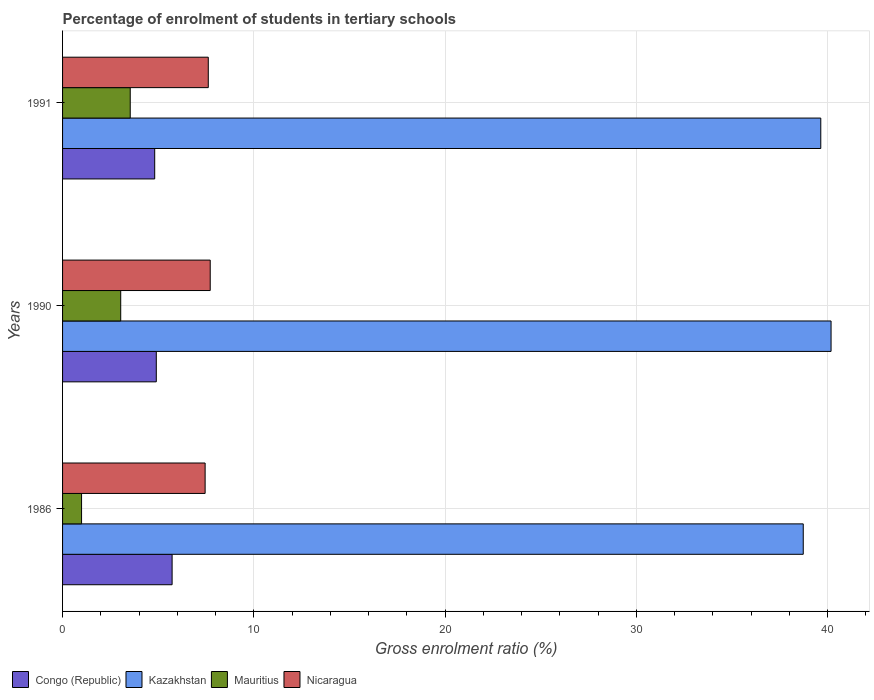Are the number of bars per tick equal to the number of legend labels?
Make the answer very short. Yes. How many bars are there on the 2nd tick from the top?
Make the answer very short. 4. How many bars are there on the 2nd tick from the bottom?
Your response must be concise. 4. What is the percentage of students enrolled in tertiary schools in Mauritius in 1991?
Your response must be concise. 3.54. Across all years, what is the maximum percentage of students enrolled in tertiary schools in Nicaragua?
Ensure brevity in your answer.  7.72. Across all years, what is the minimum percentage of students enrolled in tertiary schools in Nicaragua?
Ensure brevity in your answer.  7.45. In which year was the percentage of students enrolled in tertiary schools in Congo (Republic) maximum?
Offer a terse response. 1986. In which year was the percentage of students enrolled in tertiary schools in Congo (Republic) minimum?
Ensure brevity in your answer.  1991. What is the total percentage of students enrolled in tertiary schools in Congo (Republic) in the graph?
Offer a very short reply. 15.45. What is the difference between the percentage of students enrolled in tertiary schools in Congo (Republic) in 1986 and that in 1991?
Your answer should be compact. 0.91. What is the difference between the percentage of students enrolled in tertiary schools in Mauritius in 1991 and the percentage of students enrolled in tertiary schools in Nicaragua in 1986?
Give a very brief answer. -3.92. What is the average percentage of students enrolled in tertiary schools in Kazakhstan per year?
Ensure brevity in your answer.  39.52. In the year 1986, what is the difference between the percentage of students enrolled in tertiary schools in Mauritius and percentage of students enrolled in tertiary schools in Kazakhstan?
Offer a terse response. -37.74. In how many years, is the percentage of students enrolled in tertiary schools in Nicaragua greater than 16 %?
Give a very brief answer. 0. What is the ratio of the percentage of students enrolled in tertiary schools in Nicaragua in 1986 to that in 1990?
Your response must be concise. 0.97. What is the difference between the highest and the second highest percentage of students enrolled in tertiary schools in Nicaragua?
Make the answer very short. 0.1. What is the difference between the highest and the lowest percentage of students enrolled in tertiary schools in Mauritius?
Your answer should be compact. 2.55. Is the sum of the percentage of students enrolled in tertiary schools in Mauritius in 1986 and 1990 greater than the maximum percentage of students enrolled in tertiary schools in Nicaragua across all years?
Ensure brevity in your answer.  No. Is it the case that in every year, the sum of the percentage of students enrolled in tertiary schools in Kazakhstan and percentage of students enrolled in tertiary schools in Nicaragua is greater than the sum of percentage of students enrolled in tertiary schools in Mauritius and percentage of students enrolled in tertiary schools in Congo (Republic)?
Provide a succinct answer. No. What does the 1st bar from the top in 1991 represents?
Your response must be concise. Nicaragua. What does the 3rd bar from the bottom in 1990 represents?
Your response must be concise. Mauritius. Is it the case that in every year, the sum of the percentage of students enrolled in tertiary schools in Nicaragua and percentage of students enrolled in tertiary schools in Kazakhstan is greater than the percentage of students enrolled in tertiary schools in Congo (Republic)?
Your answer should be very brief. Yes. How many bars are there?
Offer a very short reply. 12. How many years are there in the graph?
Provide a short and direct response. 3. What is the difference between two consecutive major ticks on the X-axis?
Offer a very short reply. 10. Are the values on the major ticks of X-axis written in scientific E-notation?
Offer a very short reply. No. Does the graph contain any zero values?
Offer a terse response. No. Does the graph contain grids?
Provide a succinct answer. Yes. What is the title of the graph?
Your answer should be compact. Percentage of enrolment of students in tertiary schools. Does "Mali" appear as one of the legend labels in the graph?
Provide a succinct answer. No. What is the label or title of the Y-axis?
Make the answer very short. Years. What is the Gross enrolment ratio (%) of Congo (Republic) in 1986?
Give a very brief answer. 5.73. What is the Gross enrolment ratio (%) of Kazakhstan in 1986?
Provide a short and direct response. 38.73. What is the Gross enrolment ratio (%) of Mauritius in 1986?
Make the answer very short. 0.99. What is the Gross enrolment ratio (%) in Nicaragua in 1986?
Ensure brevity in your answer.  7.45. What is the Gross enrolment ratio (%) of Congo (Republic) in 1990?
Provide a short and direct response. 4.9. What is the Gross enrolment ratio (%) of Kazakhstan in 1990?
Your response must be concise. 40.19. What is the Gross enrolment ratio (%) in Mauritius in 1990?
Make the answer very short. 3.04. What is the Gross enrolment ratio (%) in Nicaragua in 1990?
Offer a terse response. 7.72. What is the Gross enrolment ratio (%) in Congo (Republic) in 1991?
Ensure brevity in your answer.  4.82. What is the Gross enrolment ratio (%) of Kazakhstan in 1991?
Make the answer very short. 39.65. What is the Gross enrolment ratio (%) in Mauritius in 1991?
Offer a terse response. 3.54. What is the Gross enrolment ratio (%) of Nicaragua in 1991?
Provide a short and direct response. 7.62. Across all years, what is the maximum Gross enrolment ratio (%) of Congo (Republic)?
Offer a terse response. 5.73. Across all years, what is the maximum Gross enrolment ratio (%) of Kazakhstan?
Make the answer very short. 40.19. Across all years, what is the maximum Gross enrolment ratio (%) in Mauritius?
Your answer should be very brief. 3.54. Across all years, what is the maximum Gross enrolment ratio (%) of Nicaragua?
Offer a terse response. 7.72. Across all years, what is the minimum Gross enrolment ratio (%) in Congo (Republic)?
Keep it short and to the point. 4.82. Across all years, what is the minimum Gross enrolment ratio (%) in Kazakhstan?
Ensure brevity in your answer.  38.73. Across all years, what is the minimum Gross enrolment ratio (%) of Nicaragua?
Make the answer very short. 7.45. What is the total Gross enrolment ratio (%) in Congo (Republic) in the graph?
Make the answer very short. 15.45. What is the total Gross enrolment ratio (%) of Kazakhstan in the graph?
Your response must be concise. 118.57. What is the total Gross enrolment ratio (%) in Mauritius in the graph?
Your answer should be very brief. 7.57. What is the total Gross enrolment ratio (%) in Nicaragua in the graph?
Offer a terse response. 22.8. What is the difference between the Gross enrolment ratio (%) in Congo (Republic) in 1986 and that in 1990?
Ensure brevity in your answer.  0.83. What is the difference between the Gross enrolment ratio (%) in Kazakhstan in 1986 and that in 1990?
Offer a very short reply. -1.45. What is the difference between the Gross enrolment ratio (%) in Mauritius in 1986 and that in 1990?
Offer a very short reply. -2.05. What is the difference between the Gross enrolment ratio (%) in Nicaragua in 1986 and that in 1990?
Keep it short and to the point. -0.27. What is the difference between the Gross enrolment ratio (%) in Congo (Republic) in 1986 and that in 1991?
Offer a very short reply. 0.91. What is the difference between the Gross enrolment ratio (%) in Kazakhstan in 1986 and that in 1991?
Your response must be concise. -0.92. What is the difference between the Gross enrolment ratio (%) of Mauritius in 1986 and that in 1991?
Ensure brevity in your answer.  -2.54. What is the difference between the Gross enrolment ratio (%) in Nicaragua in 1986 and that in 1991?
Offer a very short reply. -0.17. What is the difference between the Gross enrolment ratio (%) of Congo (Republic) in 1990 and that in 1991?
Offer a terse response. 0.08. What is the difference between the Gross enrolment ratio (%) of Kazakhstan in 1990 and that in 1991?
Offer a very short reply. 0.54. What is the difference between the Gross enrolment ratio (%) in Mauritius in 1990 and that in 1991?
Make the answer very short. -0.5. What is the difference between the Gross enrolment ratio (%) of Nicaragua in 1990 and that in 1991?
Your answer should be compact. 0.1. What is the difference between the Gross enrolment ratio (%) of Congo (Republic) in 1986 and the Gross enrolment ratio (%) of Kazakhstan in 1990?
Provide a succinct answer. -34.46. What is the difference between the Gross enrolment ratio (%) in Congo (Republic) in 1986 and the Gross enrolment ratio (%) in Mauritius in 1990?
Ensure brevity in your answer.  2.69. What is the difference between the Gross enrolment ratio (%) of Congo (Republic) in 1986 and the Gross enrolment ratio (%) of Nicaragua in 1990?
Make the answer very short. -1.99. What is the difference between the Gross enrolment ratio (%) in Kazakhstan in 1986 and the Gross enrolment ratio (%) in Mauritius in 1990?
Make the answer very short. 35.69. What is the difference between the Gross enrolment ratio (%) in Kazakhstan in 1986 and the Gross enrolment ratio (%) in Nicaragua in 1990?
Your answer should be compact. 31.01. What is the difference between the Gross enrolment ratio (%) in Mauritius in 1986 and the Gross enrolment ratio (%) in Nicaragua in 1990?
Your response must be concise. -6.73. What is the difference between the Gross enrolment ratio (%) in Congo (Republic) in 1986 and the Gross enrolment ratio (%) in Kazakhstan in 1991?
Your response must be concise. -33.92. What is the difference between the Gross enrolment ratio (%) of Congo (Republic) in 1986 and the Gross enrolment ratio (%) of Mauritius in 1991?
Make the answer very short. 2.19. What is the difference between the Gross enrolment ratio (%) of Congo (Republic) in 1986 and the Gross enrolment ratio (%) of Nicaragua in 1991?
Make the answer very short. -1.89. What is the difference between the Gross enrolment ratio (%) of Kazakhstan in 1986 and the Gross enrolment ratio (%) of Mauritius in 1991?
Keep it short and to the point. 35.19. What is the difference between the Gross enrolment ratio (%) in Kazakhstan in 1986 and the Gross enrolment ratio (%) in Nicaragua in 1991?
Your response must be concise. 31.11. What is the difference between the Gross enrolment ratio (%) of Mauritius in 1986 and the Gross enrolment ratio (%) of Nicaragua in 1991?
Make the answer very short. -6.63. What is the difference between the Gross enrolment ratio (%) of Congo (Republic) in 1990 and the Gross enrolment ratio (%) of Kazakhstan in 1991?
Provide a short and direct response. -34.75. What is the difference between the Gross enrolment ratio (%) in Congo (Republic) in 1990 and the Gross enrolment ratio (%) in Mauritius in 1991?
Provide a succinct answer. 1.36. What is the difference between the Gross enrolment ratio (%) in Congo (Republic) in 1990 and the Gross enrolment ratio (%) in Nicaragua in 1991?
Keep it short and to the point. -2.72. What is the difference between the Gross enrolment ratio (%) in Kazakhstan in 1990 and the Gross enrolment ratio (%) in Mauritius in 1991?
Your answer should be compact. 36.65. What is the difference between the Gross enrolment ratio (%) in Kazakhstan in 1990 and the Gross enrolment ratio (%) in Nicaragua in 1991?
Give a very brief answer. 32.57. What is the difference between the Gross enrolment ratio (%) of Mauritius in 1990 and the Gross enrolment ratio (%) of Nicaragua in 1991?
Your response must be concise. -4.58. What is the average Gross enrolment ratio (%) in Congo (Republic) per year?
Offer a very short reply. 5.15. What is the average Gross enrolment ratio (%) of Kazakhstan per year?
Give a very brief answer. 39.52. What is the average Gross enrolment ratio (%) in Mauritius per year?
Offer a very short reply. 2.52. What is the average Gross enrolment ratio (%) in Nicaragua per year?
Your answer should be very brief. 7.6. In the year 1986, what is the difference between the Gross enrolment ratio (%) in Congo (Republic) and Gross enrolment ratio (%) in Kazakhstan?
Give a very brief answer. -33. In the year 1986, what is the difference between the Gross enrolment ratio (%) in Congo (Republic) and Gross enrolment ratio (%) in Mauritius?
Provide a succinct answer. 4.73. In the year 1986, what is the difference between the Gross enrolment ratio (%) of Congo (Republic) and Gross enrolment ratio (%) of Nicaragua?
Provide a succinct answer. -1.73. In the year 1986, what is the difference between the Gross enrolment ratio (%) of Kazakhstan and Gross enrolment ratio (%) of Mauritius?
Give a very brief answer. 37.74. In the year 1986, what is the difference between the Gross enrolment ratio (%) in Kazakhstan and Gross enrolment ratio (%) in Nicaragua?
Provide a short and direct response. 31.28. In the year 1986, what is the difference between the Gross enrolment ratio (%) of Mauritius and Gross enrolment ratio (%) of Nicaragua?
Give a very brief answer. -6.46. In the year 1990, what is the difference between the Gross enrolment ratio (%) of Congo (Republic) and Gross enrolment ratio (%) of Kazakhstan?
Offer a very short reply. -35.28. In the year 1990, what is the difference between the Gross enrolment ratio (%) in Congo (Republic) and Gross enrolment ratio (%) in Mauritius?
Offer a terse response. 1.86. In the year 1990, what is the difference between the Gross enrolment ratio (%) of Congo (Republic) and Gross enrolment ratio (%) of Nicaragua?
Give a very brief answer. -2.82. In the year 1990, what is the difference between the Gross enrolment ratio (%) of Kazakhstan and Gross enrolment ratio (%) of Mauritius?
Your answer should be compact. 37.15. In the year 1990, what is the difference between the Gross enrolment ratio (%) of Kazakhstan and Gross enrolment ratio (%) of Nicaragua?
Your answer should be compact. 32.47. In the year 1990, what is the difference between the Gross enrolment ratio (%) of Mauritius and Gross enrolment ratio (%) of Nicaragua?
Your answer should be very brief. -4.68. In the year 1991, what is the difference between the Gross enrolment ratio (%) of Congo (Republic) and Gross enrolment ratio (%) of Kazakhstan?
Make the answer very short. -34.83. In the year 1991, what is the difference between the Gross enrolment ratio (%) in Congo (Republic) and Gross enrolment ratio (%) in Mauritius?
Give a very brief answer. 1.28. In the year 1991, what is the difference between the Gross enrolment ratio (%) in Congo (Republic) and Gross enrolment ratio (%) in Nicaragua?
Provide a short and direct response. -2.8. In the year 1991, what is the difference between the Gross enrolment ratio (%) in Kazakhstan and Gross enrolment ratio (%) in Mauritius?
Your answer should be very brief. 36.11. In the year 1991, what is the difference between the Gross enrolment ratio (%) of Kazakhstan and Gross enrolment ratio (%) of Nicaragua?
Ensure brevity in your answer.  32.03. In the year 1991, what is the difference between the Gross enrolment ratio (%) of Mauritius and Gross enrolment ratio (%) of Nicaragua?
Your answer should be very brief. -4.08. What is the ratio of the Gross enrolment ratio (%) in Congo (Republic) in 1986 to that in 1990?
Provide a short and direct response. 1.17. What is the ratio of the Gross enrolment ratio (%) in Kazakhstan in 1986 to that in 1990?
Your answer should be very brief. 0.96. What is the ratio of the Gross enrolment ratio (%) of Mauritius in 1986 to that in 1990?
Your answer should be compact. 0.33. What is the ratio of the Gross enrolment ratio (%) in Nicaragua in 1986 to that in 1990?
Your response must be concise. 0.97. What is the ratio of the Gross enrolment ratio (%) in Congo (Republic) in 1986 to that in 1991?
Provide a short and direct response. 1.19. What is the ratio of the Gross enrolment ratio (%) of Kazakhstan in 1986 to that in 1991?
Offer a very short reply. 0.98. What is the ratio of the Gross enrolment ratio (%) of Mauritius in 1986 to that in 1991?
Ensure brevity in your answer.  0.28. What is the ratio of the Gross enrolment ratio (%) in Nicaragua in 1986 to that in 1991?
Provide a short and direct response. 0.98. What is the ratio of the Gross enrolment ratio (%) of Congo (Republic) in 1990 to that in 1991?
Your answer should be compact. 1.02. What is the ratio of the Gross enrolment ratio (%) of Kazakhstan in 1990 to that in 1991?
Offer a very short reply. 1.01. What is the ratio of the Gross enrolment ratio (%) of Mauritius in 1990 to that in 1991?
Your answer should be compact. 0.86. What is the ratio of the Gross enrolment ratio (%) in Nicaragua in 1990 to that in 1991?
Offer a very short reply. 1.01. What is the difference between the highest and the second highest Gross enrolment ratio (%) of Congo (Republic)?
Keep it short and to the point. 0.83. What is the difference between the highest and the second highest Gross enrolment ratio (%) of Kazakhstan?
Keep it short and to the point. 0.54. What is the difference between the highest and the second highest Gross enrolment ratio (%) of Mauritius?
Your answer should be compact. 0.5. What is the difference between the highest and the second highest Gross enrolment ratio (%) of Nicaragua?
Give a very brief answer. 0.1. What is the difference between the highest and the lowest Gross enrolment ratio (%) of Congo (Republic)?
Offer a very short reply. 0.91. What is the difference between the highest and the lowest Gross enrolment ratio (%) in Kazakhstan?
Make the answer very short. 1.45. What is the difference between the highest and the lowest Gross enrolment ratio (%) of Mauritius?
Provide a succinct answer. 2.54. What is the difference between the highest and the lowest Gross enrolment ratio (%) in Nicaragua?
Your answer should be compact. 0.27. 